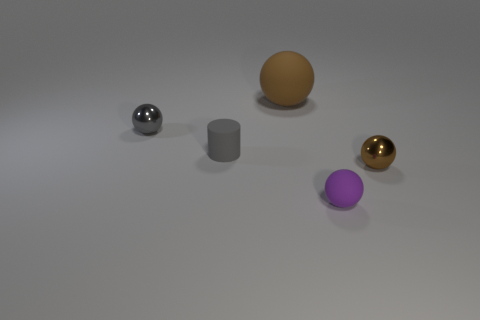Are there any other things that are the same size as the gray matte cylinder?
Make the answer very short. Yes. There is a tiny rubber sphere; is its color the same as the rubber object that is behind the tiny gray matte cylinder?
Your response must be concise. No. Are there the same number of small balls that are behind the brown rubber object and tiny matte cylinders in front of the tiny cylinder?
Give a very brief answer. Yes. What is the material of the large object that is to the right of the small gray shiny sphere?
Your answer should be compact. Rubber. How many things are tiny things right of the big sphere or big brown rubber objects?
Offer a terse response. 3. What number of other objects are the same shape as the tiny gray metallic object?
Your answer should be compact. 3. There is a brown thing that is in front of the large brown rubber ball; does it have the same shape as the brown rubber thing?
Give a very brief answer. Yes. There is a small brown metallic thing; are there any shiny things right of it?
Your answer should be compact. No. How many tiny objects are spheres or gray balls?
Provide a short and direct response. 3. Does the tiny purple ball have the same material as the gray cylinder?
Your response must be concise. Yes. 